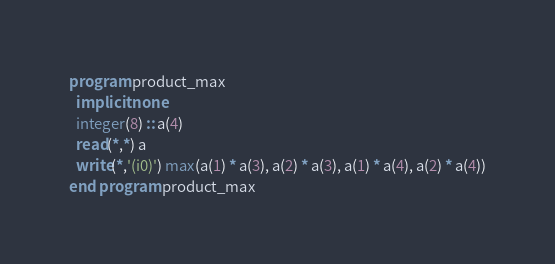Convert code to text. <code><loc_0><loc_0><loc_500><loc_500><_FORTRAN_>program product_max
  implicit none
  integer(8) :: a(4)
  read(*,*) a
  write(*,'(i0)') max(a(1) * a(3), a(2) * a(3), a(1) * a(4), a(2) * a(4))
end program product_max</code> 